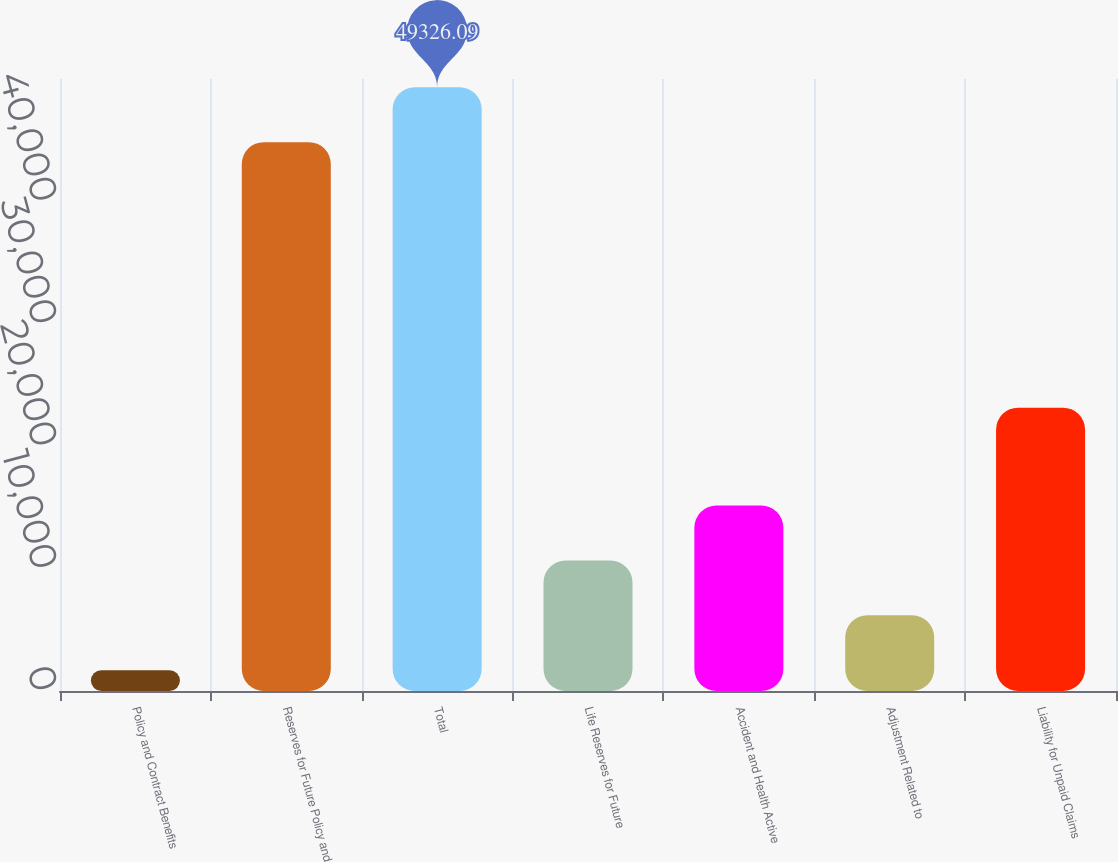Convert chart. <chart><loc_0><loc_0><loc_500><loc_500><bar_chart><fcel>Policy and Contract Benefits<fcel>Reserves for Future Policy and<fcel>Total<fcel>Life Reserves for Future<fcel>Accident and Health Active<fcel>Adjustment Related to<fcel>Liability for Unpaid Claims<nl><fcel>1695.7<fcel>44841.9<fcel>49326.1<fcel>10664.1<fcel>15148.3<fcel>6179.89<fcel>23149<nl></chart> 